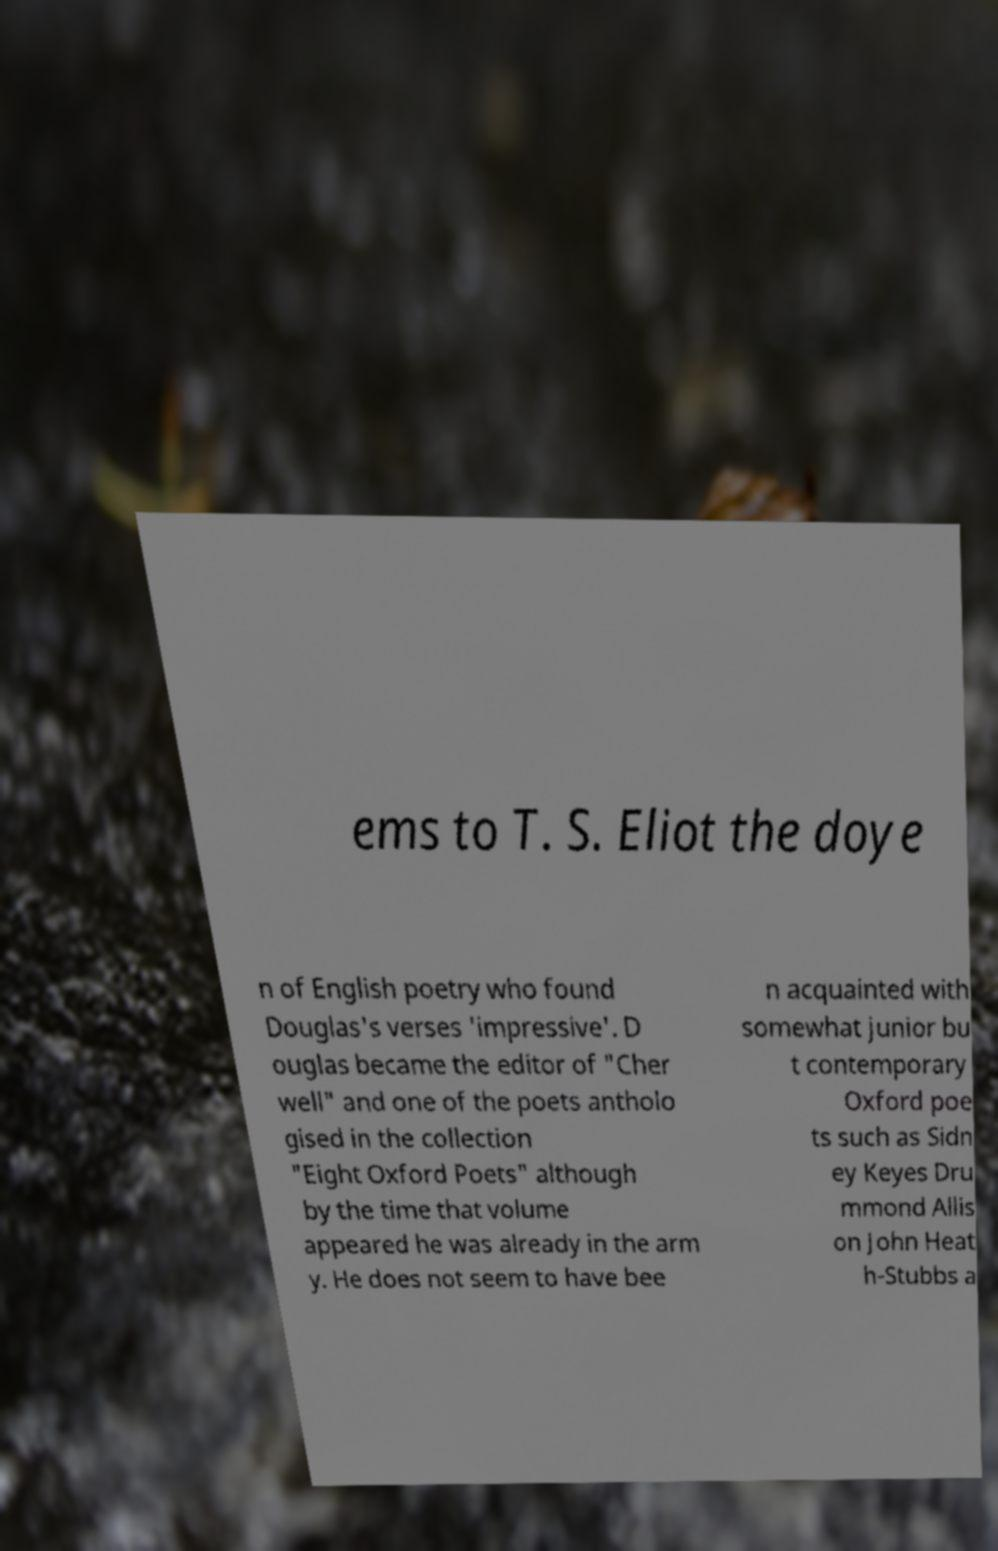Can you read and provide the text displayed in the image?This photo seems to have some interesting text. Can you extract and type it out for me? ems to T. S. Eliot the doye n of English poetry who found Douglas's verses 'impressive'. D ouglas became the editor of "Cher well" and one of the poets antholo gised in the collection "Eight Oxford Poets" although by the time that volume appeared he was already in the arm y. He does not seem to have bee n acquainted with somewhat junior bu t contemporary Oxford poe ts such as Sidn ey Keyes Dru mmond Allis on John Heat h-Stubbs a 